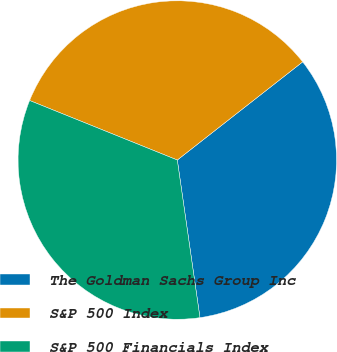Convert chart to OTSL. <chart><loc_0><loc_0><loc_500><loc_500><pie_chart><fcel>The Goldman Sachs Group Inc<fcel>S&P 500 Index<fcel>S&P 500 Financials Index<nl><fcel>33.3%<fcel>33.33%<fcel>33.37%<nl></chart> 